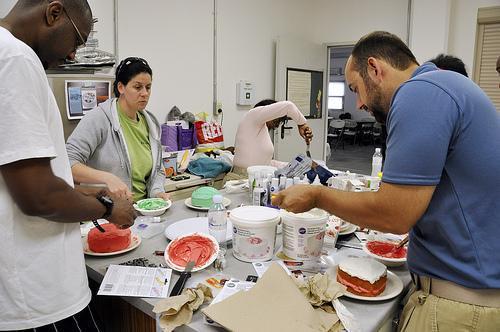How many people are in the picture?
Give a very brief answer. 4. How many people are wearing the color blue?
Give a very brief answer. 1. 